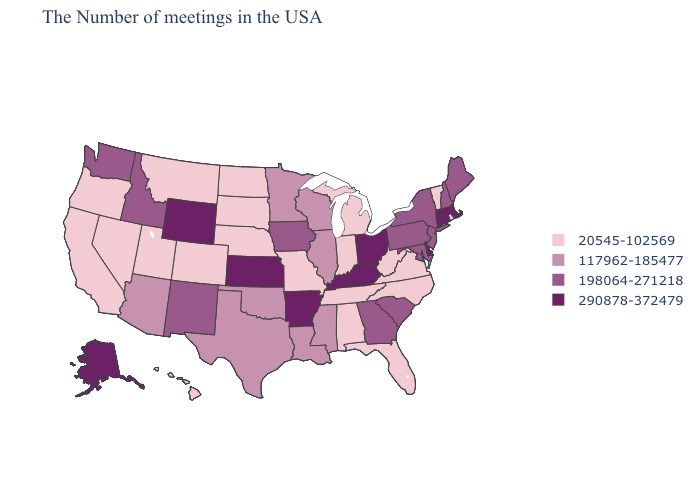Among the states that border Mississippi , does Arkansas have the highest value?
Be succinct. Yes. Name the states that have a value in the range 290878-372479?
Quick response, please. Massachusetts, Connecticut, Delaware, Ohio, Kentucky, Arkansas, Kansas, Wyoming, Alaska. Does the first symbol in the legend represent the smallest category?
Keep it brief. Yes. Which states have the highest value in the USA?
Keep it brief. Massachusetts, Connecticut, Delaware, Ohio, Kentucky, Arkansas, Kansas, Wyoming, Alaska. What is the value of Delaware?
Be succinct. 290878-372479. Name the states that have a value in the range 117962-185477?
Give a very brief answer. Wisconsin, Illinois, Mississippi, Louisiana, Minnesota, Oklahoma, Texas, Arizona. Among the states that border Illinois , which have the highest value?
Be succinct. Kentucky. What is the lowest value in the South?
Quick response, please. 20545-102569. Among the states that border Ohio , which have the lowest value?
Give a very brief answer. West Virginia, Michigan, Indiana. Is the legend a continuous bar?
Concise answer only. No. What is the lowest value in the Northeast?
Concise answer only. 20545-102569. What is the highest value in the USA?
Answer briefly. 290878-372479. What is the value of Nebraska?
Concise answer only. 20545-102569. Name the states that have a value in the range 20545-102569?
Give a very brief answer. Rhode Island, Vermont, Virginia, North Carolina, West Virginia, Florida, Michigan, Indiana, Alabama, Tennessee, Missouri, Nebraska, South Dakota, North Dakota, Colorado, Utah, Montana, Nevada, California, Oregon, Hawaii. Which states have the highest value in the USA?
Answer briefly. Massachusetts, Connecticut, Delaware, Ohio, Kentucky, Arkansas, Kansas, Wyoming, Alaska. 